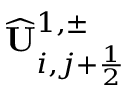<formula> <loc_0><loc_0><loc_500><loc_500>\widehat { U } _ { i , j + \frac { 1 } { 2 } } ^ { 1 , \pm }</formula> 